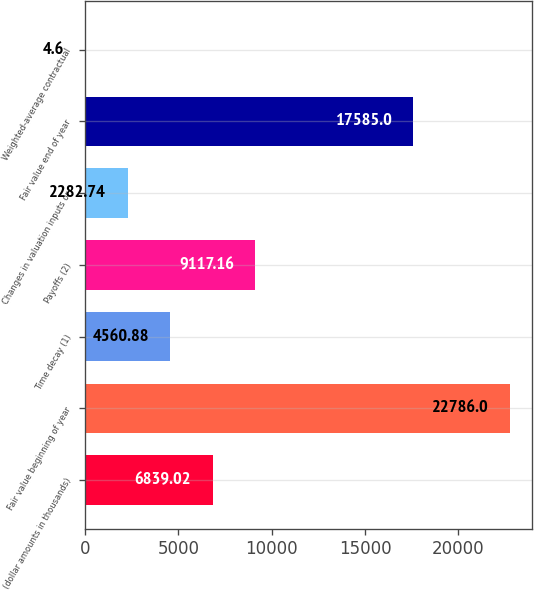<chart> <loc_0><loc_0><loc_500><loc_500><bar_chart><fcel>(dollar amounts in thousands)<fcel>Fair value beginning of year<fcel>Time decay (1)<fcel>Payoffs (2)<fcel>Changes in valuation inputs or<fcel>Fair value end of year<fcel>Weighted-average contractual<nl><fcel>6839.02<fcel>22786<fcel>4560.88<fcel>9117.16<fcel>2282.74<fcel>17585<fcel>4.6<nl></chart> 